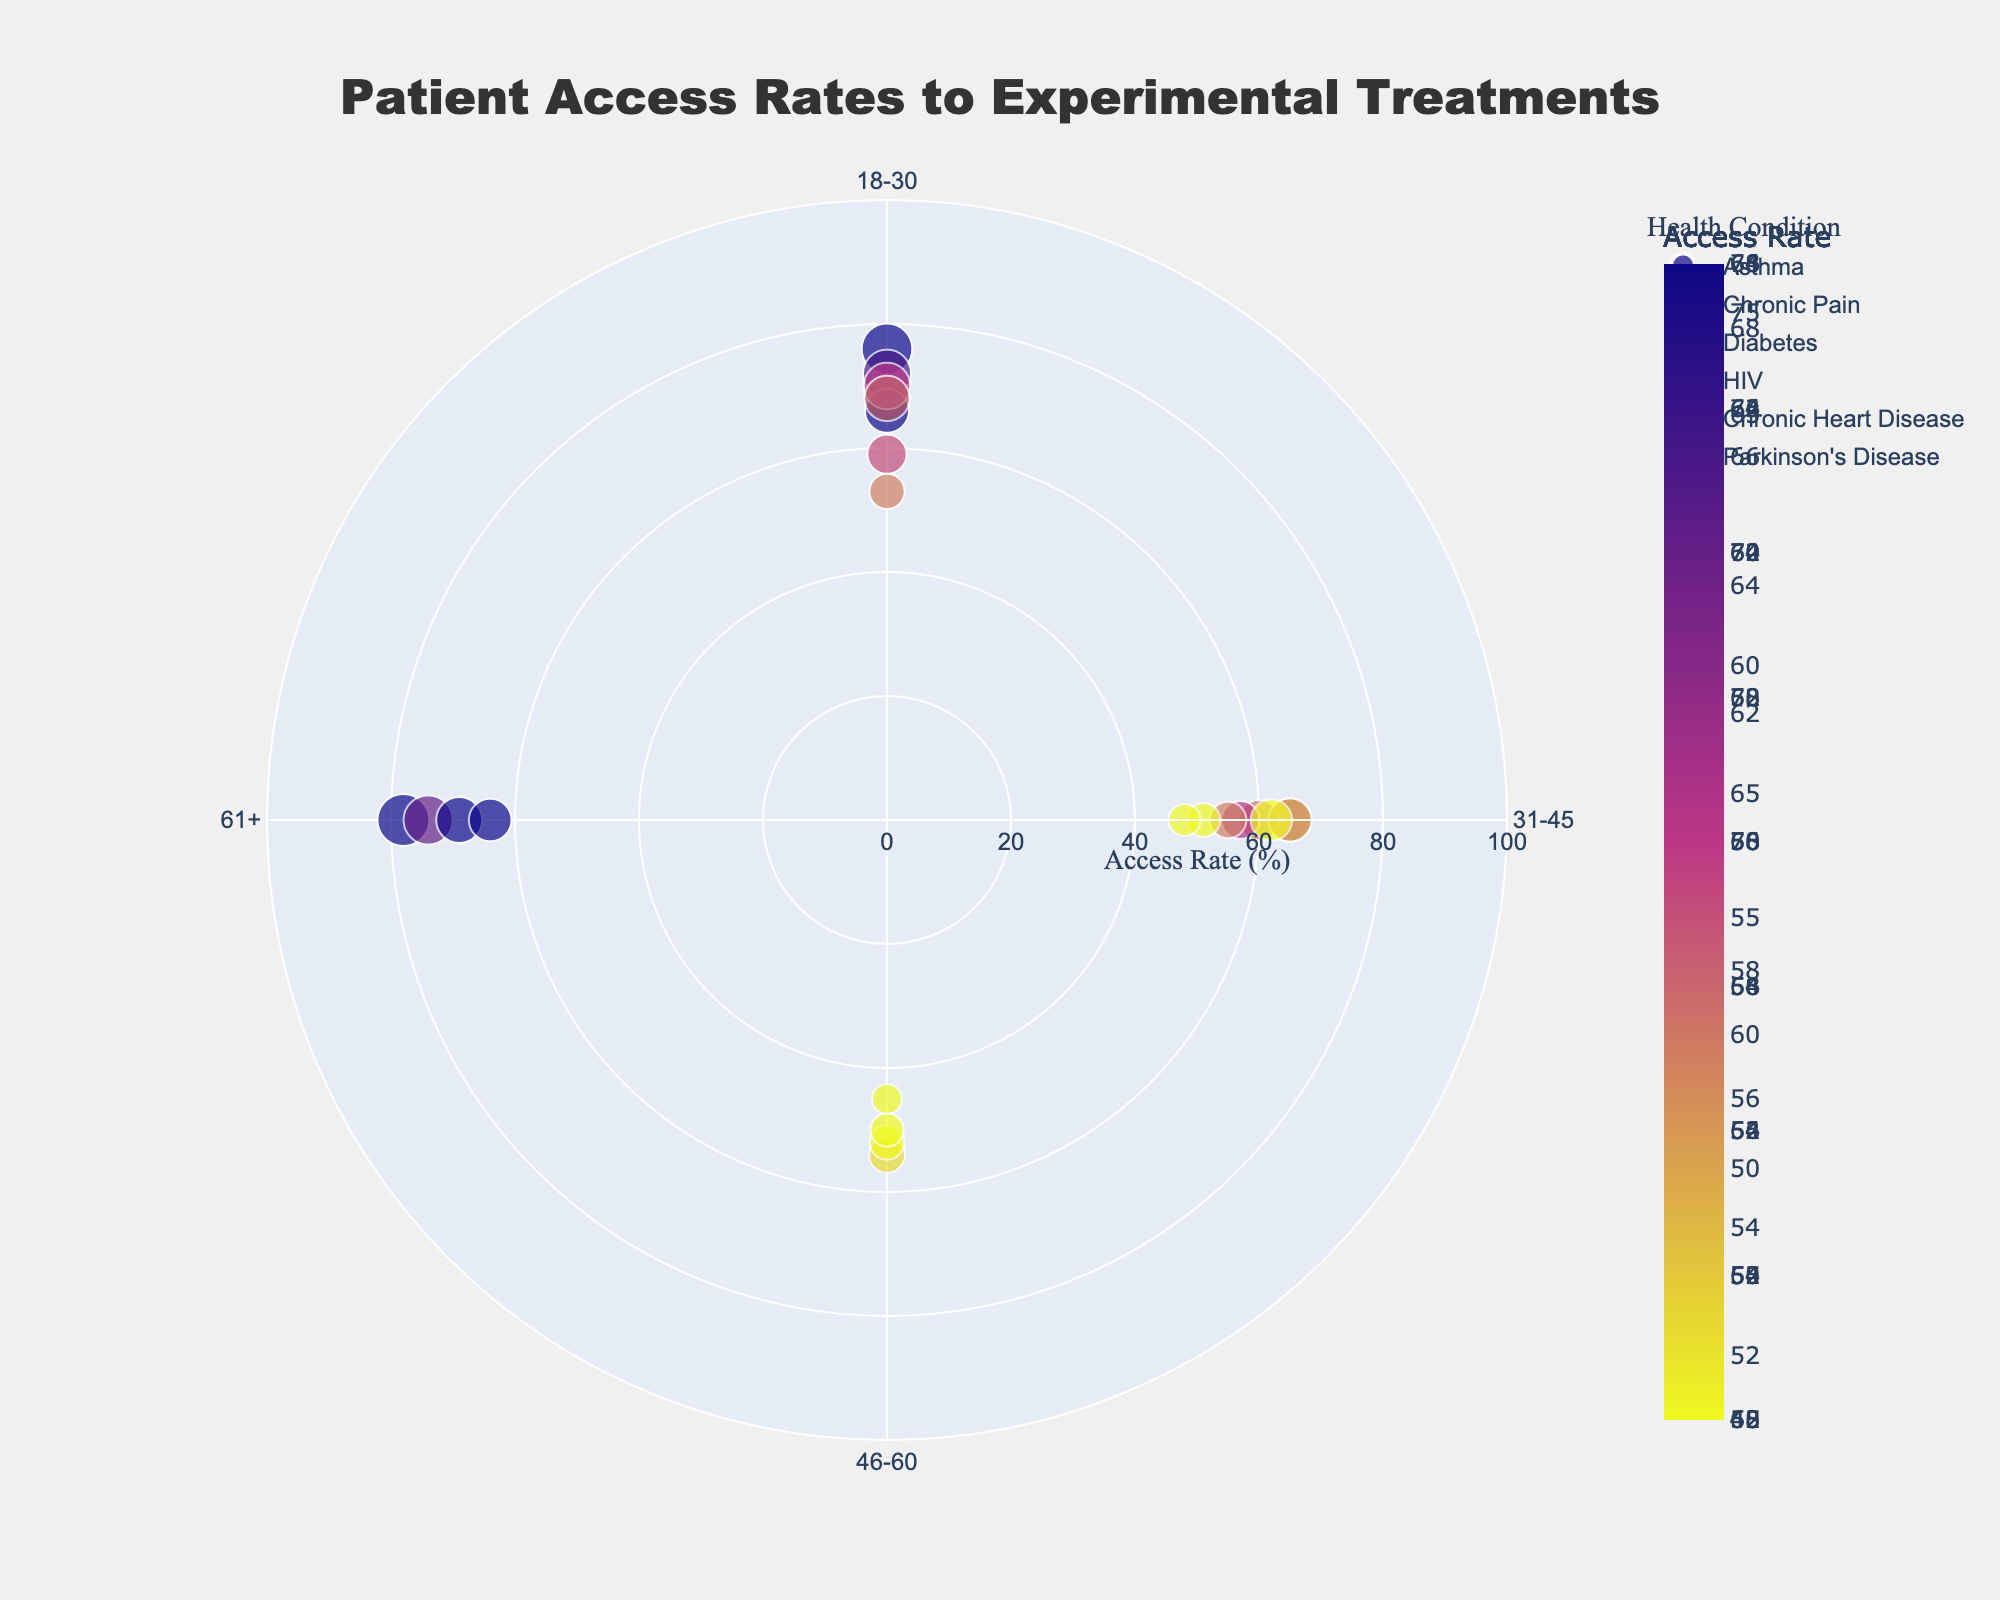What's the title of the figure? The title is displayed prominently at the top of the figure and it reads 'Patient Access Rates to Experimental Treatments'.
Answer: Patient Access Rates to Experimental Treatments How many age groups are represented in the figure? The age groups are marked on the angular axis, which has distinct labels. There are four labeled age groups: '18-30', '31-45', '46-60', and '61+'.
Answer: 4 Which health condition shows the highest access rate for the age group 18-30? We look at the markers located in the section labeled '18-30' and compare the access rates. The highest marker value in this section is 78, which is associated with HIV.
Answer: HIV Which health condition has the lowest access rate for the age group 61+? We examine the markers in the '61+' section and find the smallest access rate value, which is 48 for Parkinson's Disease.
Answer: Parkinson's Disease For the age group 46-60, what is the difference in access rates between mild and severe chronic pain conditions? We locate the relevant values for 46-60 with chronic pain: Mild (68) and Severe (45). The difference is calculated as 68 - 45.
Answer: 23 Is there any age group where the access rate for moderate severity is greater than that for mild severity for any health condition? We check each age group. For each health condition, we see that the access rate for moderate severity is always less than that for mild severity across all age groups.
Answer: No What's the trend in access rates across severity levels (Mild, Moderate, Severe) for asthma in the age group 31-45? For asthma in 31-45, the access rates are Mild (72), Moderate (60), and Severe (52). The trend shows a decrease from Mild to Severe.
Answer: Decrease Compare the access rates for severe conditions between Asthma and Diabetes for all age groups. Which one generally has higher access rates? We compare severe access rates across age groups: Asthma (54, 52) and Diabetes (50). Asthma generally shows higher access rates than Diabetes in the available data.
Answer: Asthma What are the two health conditions with the closest access rates for moderate severity in the 46-60 age group, and what are their respective rates? For 46-60, we compare moderate access rates: Chronic Pain (57) and Chronic Heart Disease (59) are closest, with a difference of 2 points.
Answer: Chronic Pain and Chronic Heart Disease, 57 and 59 Looking at the color scale, which severity level tends to have the darkest marker colors, and what does this indicate? Darker colors on the color scale represent lower access rates. Observing marker colors, the severe level tends to have the darkest colors, indicating lower access rates across conditions and age groups.
Answer: Severe 